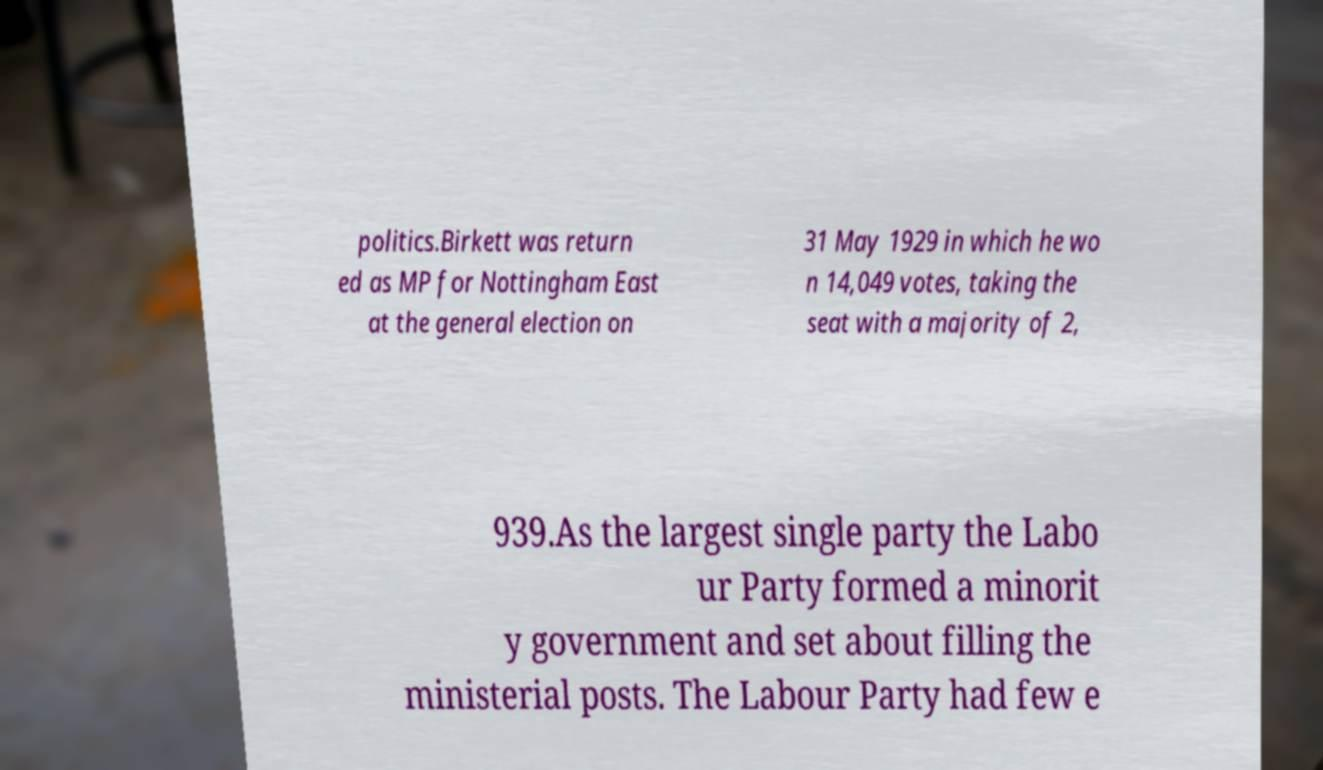Can you read and provide the text displayed in the image?This photo seems to have some interesting text. Can you extract and type it out for me? politics.Birkett was return ed as MP for Nottingham East at the general election on 31 May 1929 in which he wo n 14,049 votes, taking the seat with a majority of 2, 939.As the largest single party the Labo ur Party formed a minorit y government and set about filling the ministerial posts. The Labour Party had few e 